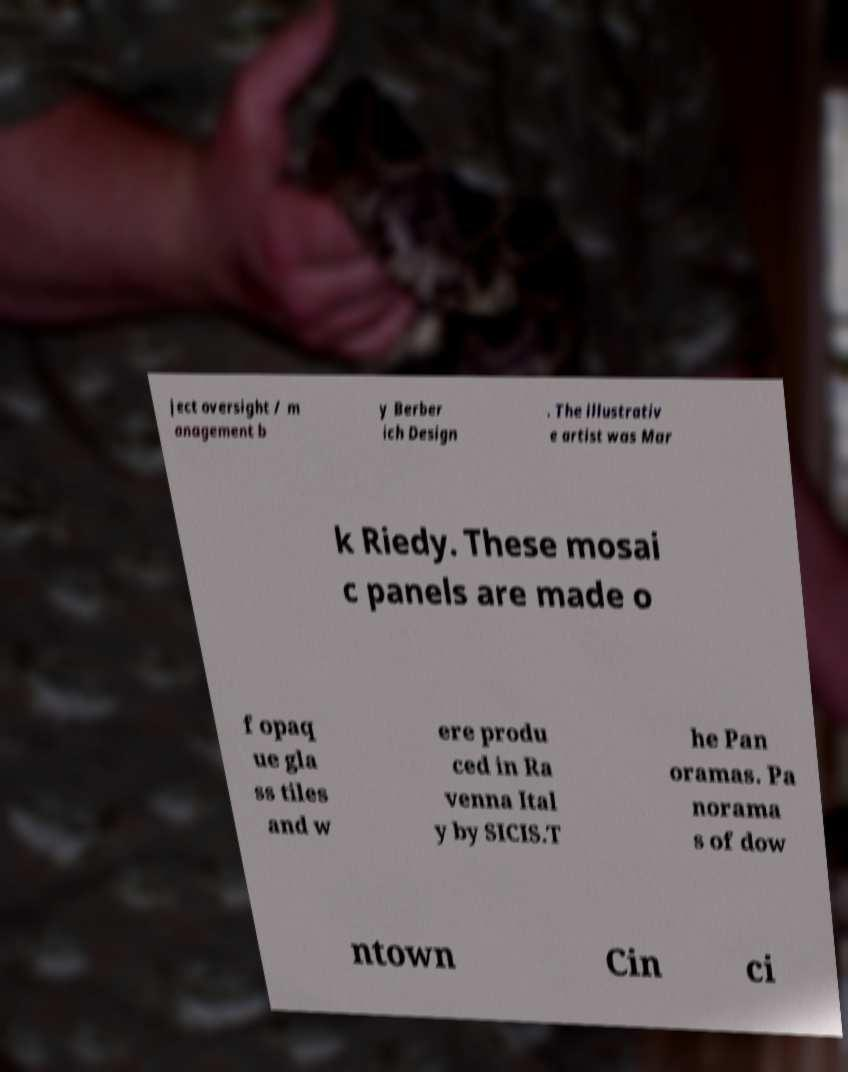Please identify and transcribe the text found in this image. ject oversight / m anagement b y Berber ich Design . The illustrativ e artist was Mar k Riedy. These mosai c panels are made o f opaq ue gla ss tiles and w ere produ ced in Ra venna Ital y by SICIS.T he Pan oramas. Pa norama s of dow ntown Cin ci 